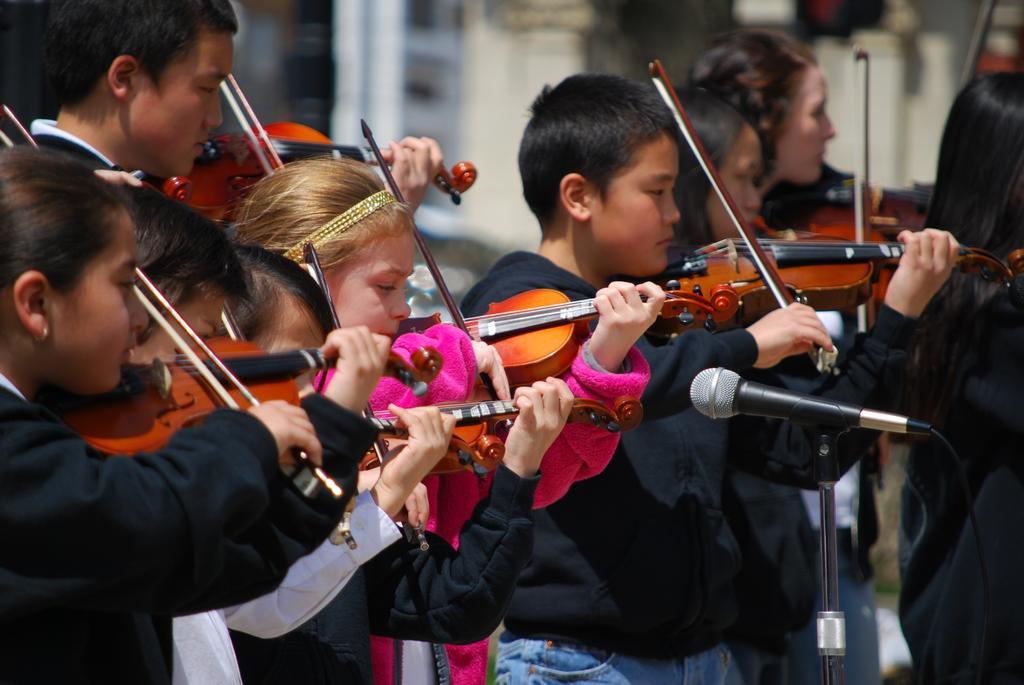Can you describe this image briefly? Group of people standing and playing musical instrument,in front of these people we can see microphone with stand. 